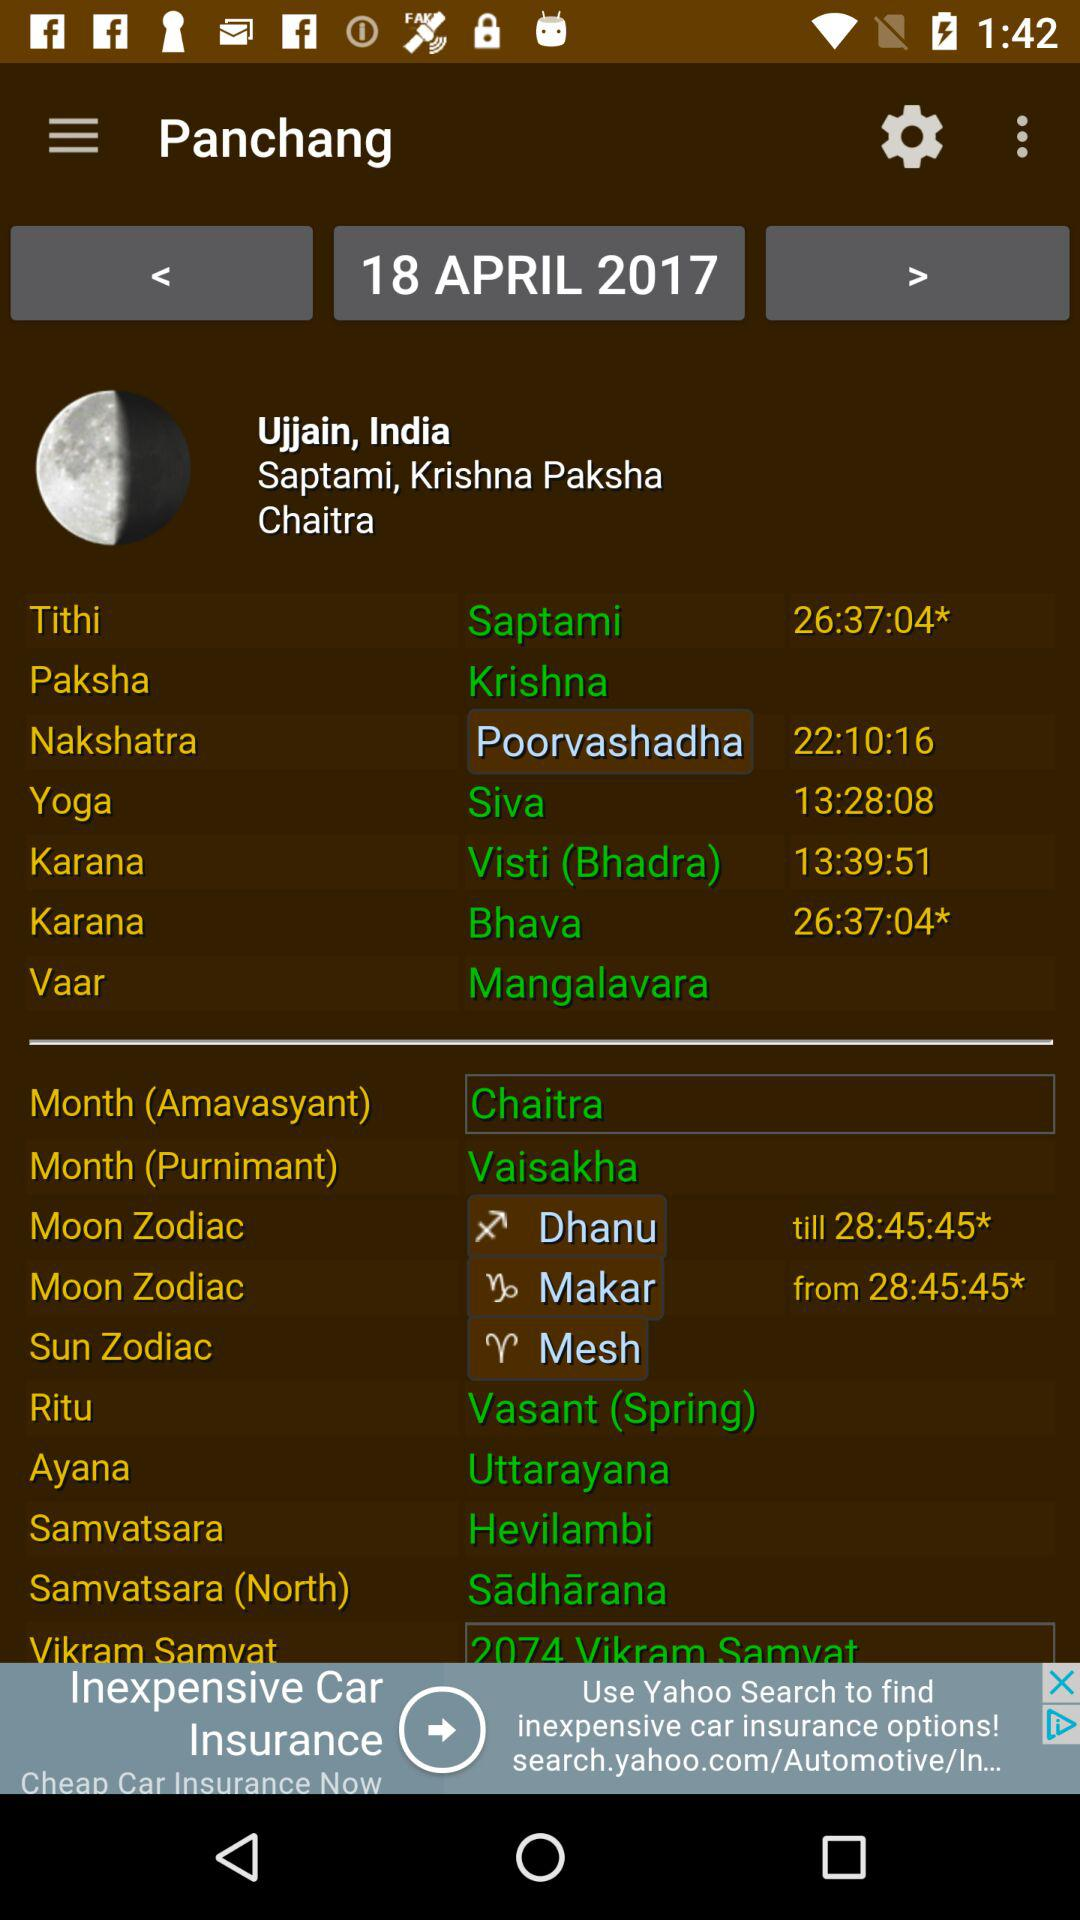What is the application name?
When the provided information is insufficient, respond with <no answer>. <no answer> 